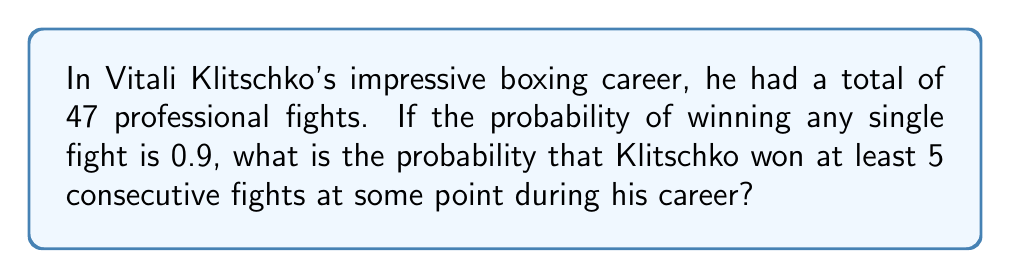Show me your answer to this math problem. Let's approach this step-by-step:

1) First, we need to calculate the probability of NOT having at least 5 consecutive wins. This is easier than calculating the probability directly.

2) Let $a_n$ be the probability of not having 5 consecutive wins in $n$ fights. We can set up a recurrence relation:

   $a_n = a_{n-1} - 0.9^5 \cdot a_{n-6}$ for $n \geq 6$

   This is because the probability of not having 5 consecutive wins in $n$ fights is the probability of not having 5 consecutive wins in $n-1$ fights, minus the probability of having exactly 5 consecutive wins ending at the $n$th fight.

3) Initial conditions:
   $a_1 = a_2 = a_3 = a_4 = 1$
   $a_5 = 1 - 0.9^5 = 0.59049$

4) We can now calculate $a_{47}$ using this recurrence relation:

   $a_6 = 1 - 0.9^5 = 0.59049$
   $a_7 = 0.59049 - 0.9^5 \cdot 1 = 0.18098$
   ...
   $a_{47} \approx 1.0242 \times 10^{-16}$

5) The probability we're looking for is $1 - a_{47}$:

   $P(\text{at least 5 consecutive wins}) = 1 - a_{47} \approx 0.9999999999999999$

This probability is extremely close to 1, which makes sense given Klitschko's high win probability and long career.
Answer: $0.9999999999999999$ 